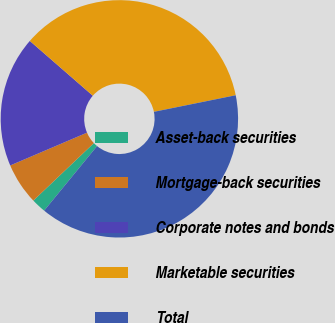Convert chart to OTSL. <chart><loc_0><loc_0><loc_500><loc_500><pie_chart><fcel>Asset-back securities<fcel>Mortgage-back securities<fcel>Corporate notes and bonds<fcel>Marketable securities<fcel>Total<nl><fcel>1.98%<fcel>5.67%<fcel>17.82%<fcel>35.42%<fcel>39.11%<nl></chart> 